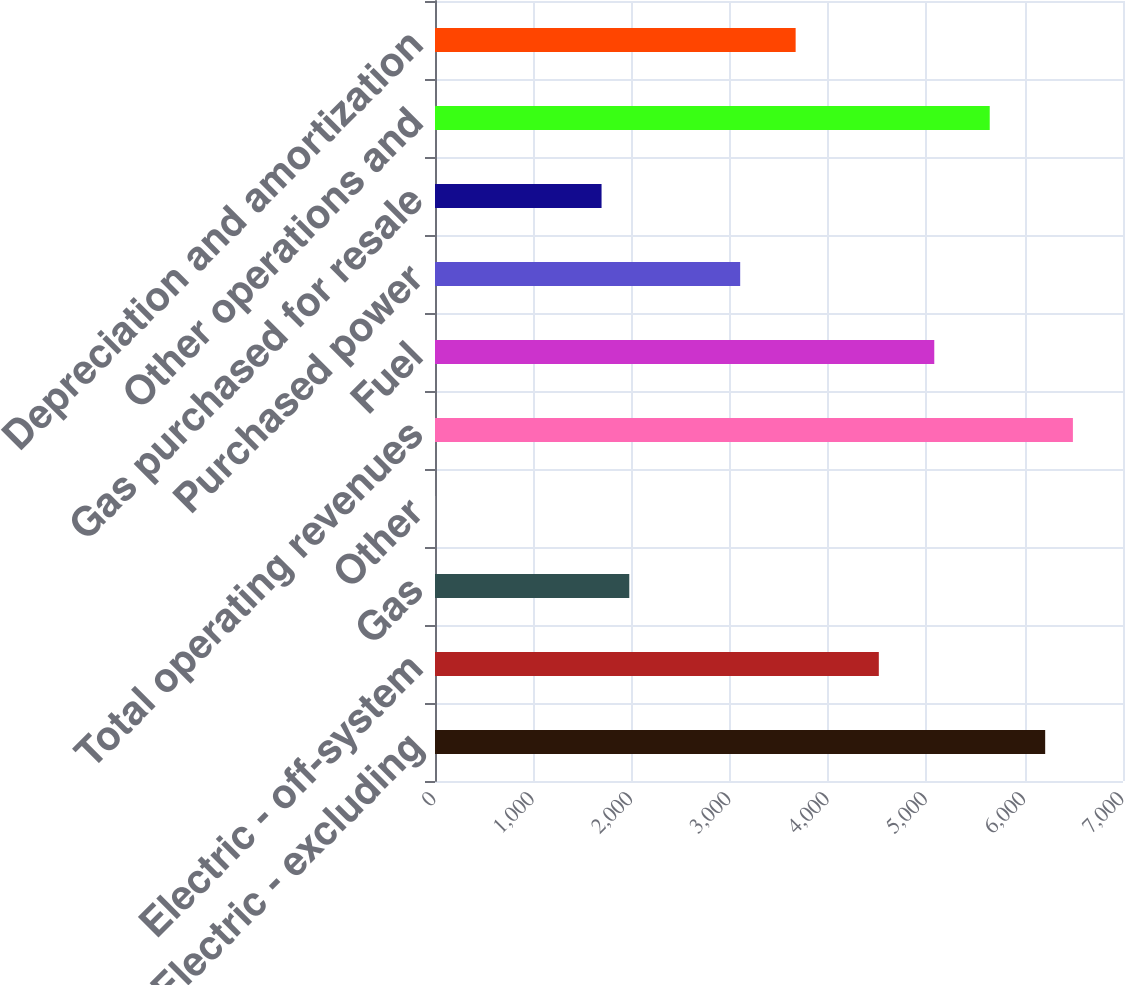Convert chart to OTSL. <chart><loc_0><loc_0><loc_500><loc_500><bar_chart><fcel>Electric - excluding<fcel>Electric - off-system<fcel>Gas<fcel>Other<fcel>Total operating revenues<fcel>Fuel<fcel>Purchased power<fcel>Gas purchased for resale<fcel>Other operations and<fcel>Depreciation and amortization<nl><fcel>6208.2<fcel>4515.6<fcel>1976.7<fcel>2<fcel>6490.3<fcel>5079.8<fcel>3105.1<fcel>1694.6<fcel>5644<fcel>3669.3<nl></chart> 